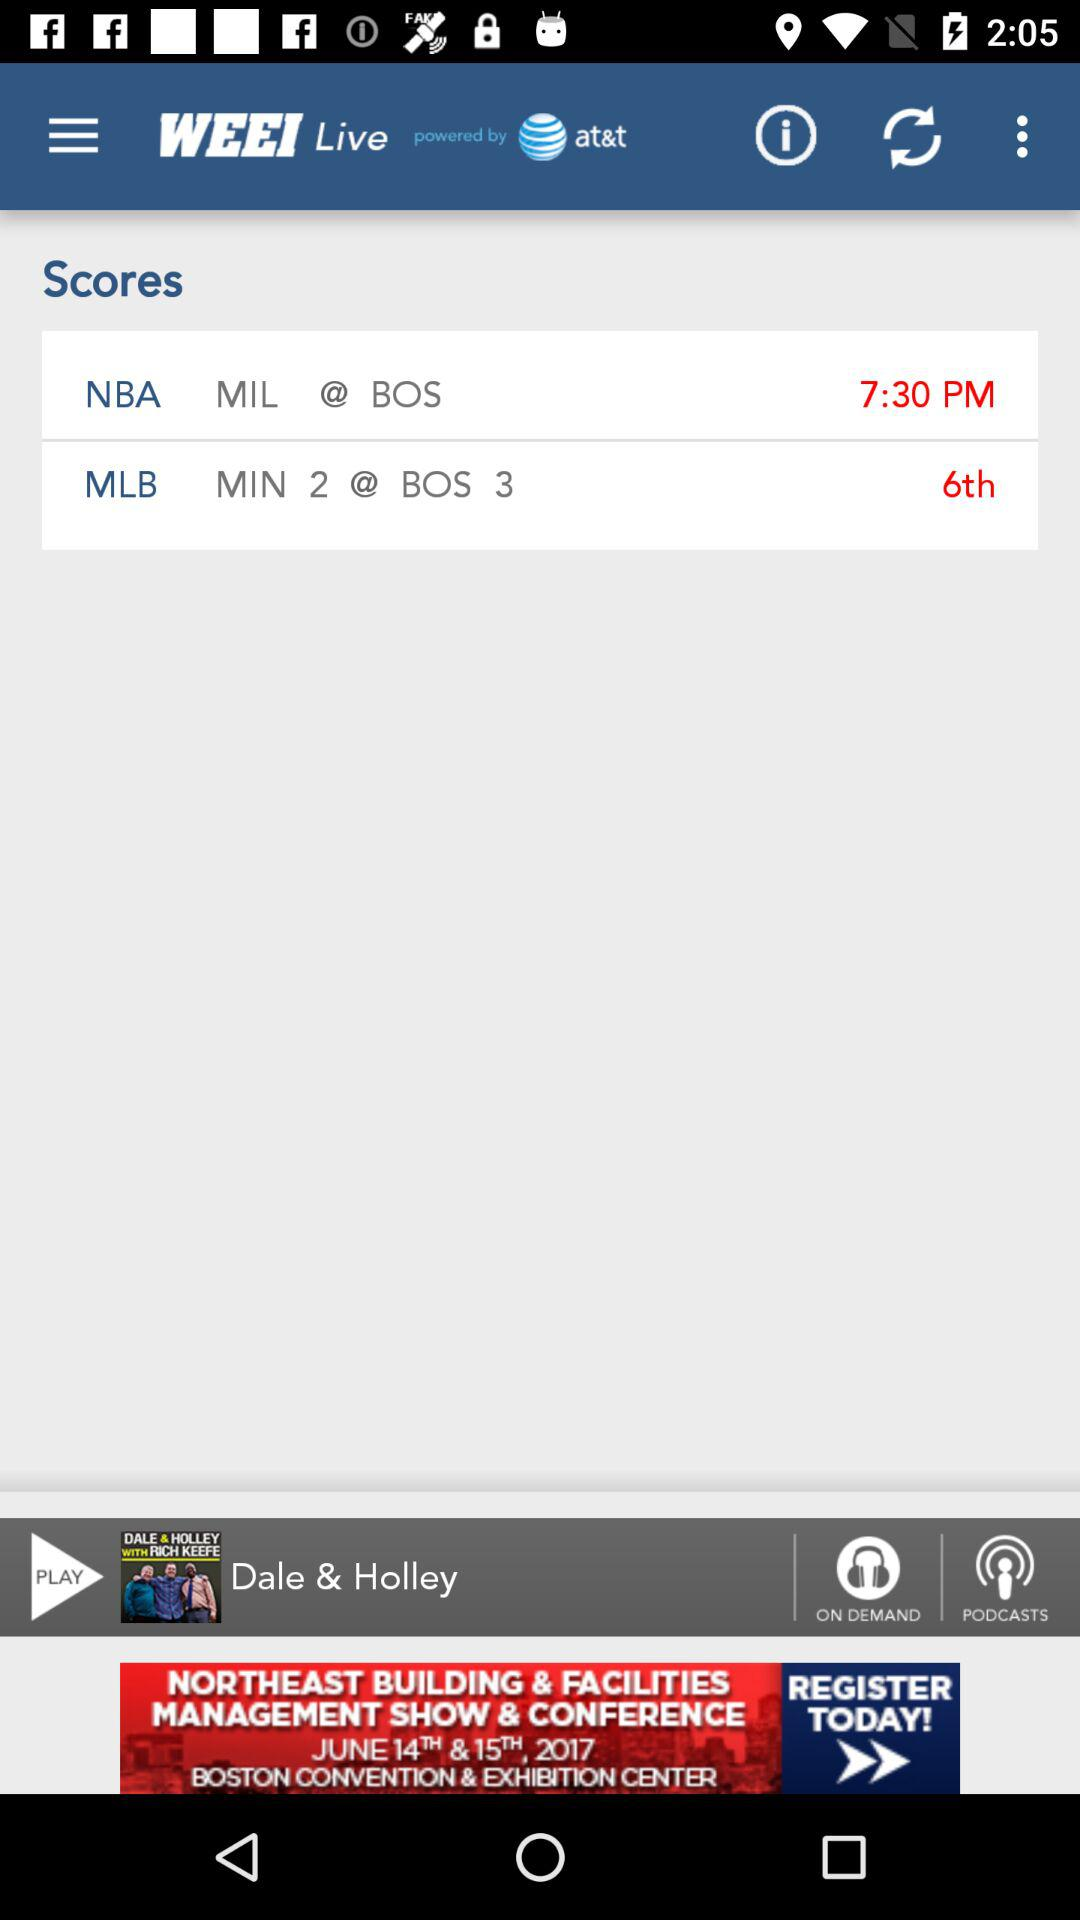What is the time of the NBA match? The time of the NBA match is 7:30 PM. 